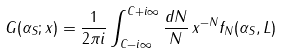Convert formula to latex. <formula><loc_0><loc_0><loc_500><loc_500>G ( \alpha _ { S } ; x ) = \frac { 1 } { 2 \pi i } \int _ { C - i \infty } ^ { C + i \infty } \frac { d N } { N } \, x ^ { - N } f _ { N } ( \alpha _ { S } , L )</formula> 